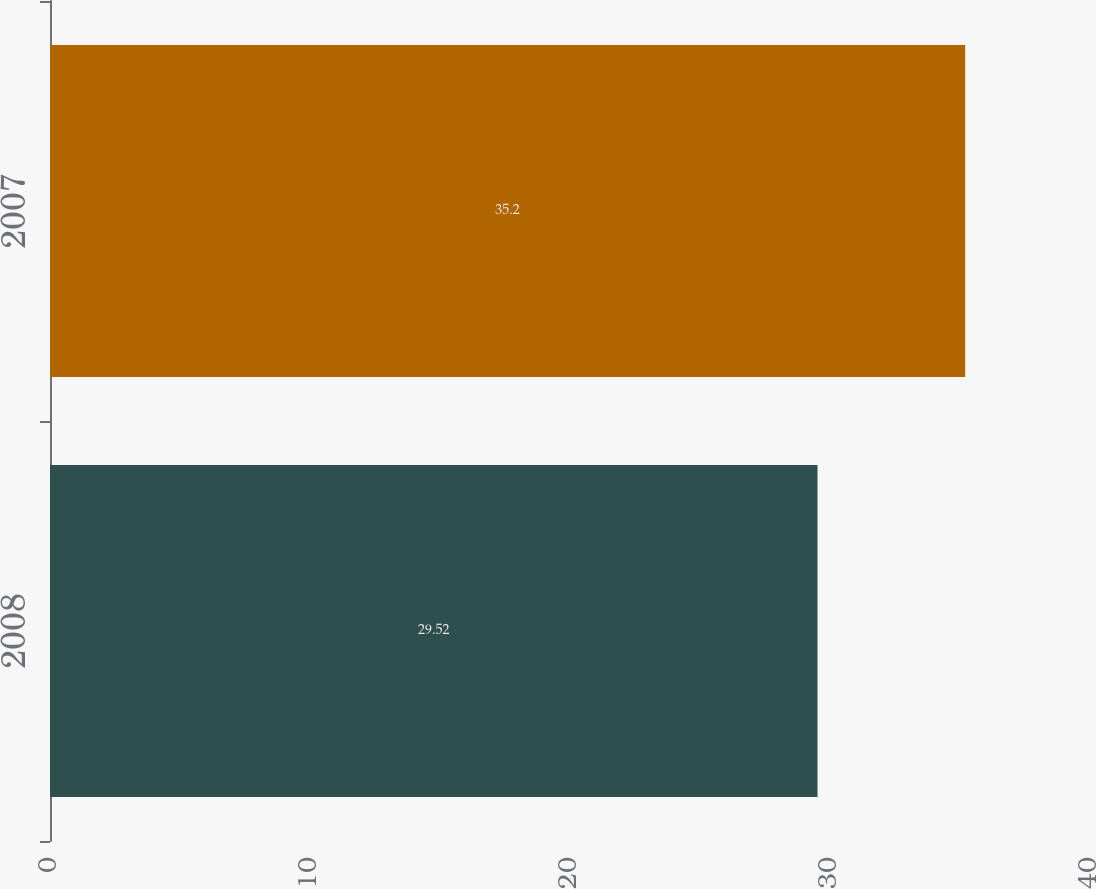<chart> <loc_0><loc_0><loc_500><loc_500><bar_chart><fcel>2008<fcel>2007<nl><fcel>29.52<fcel>35.2<nl></chart> 